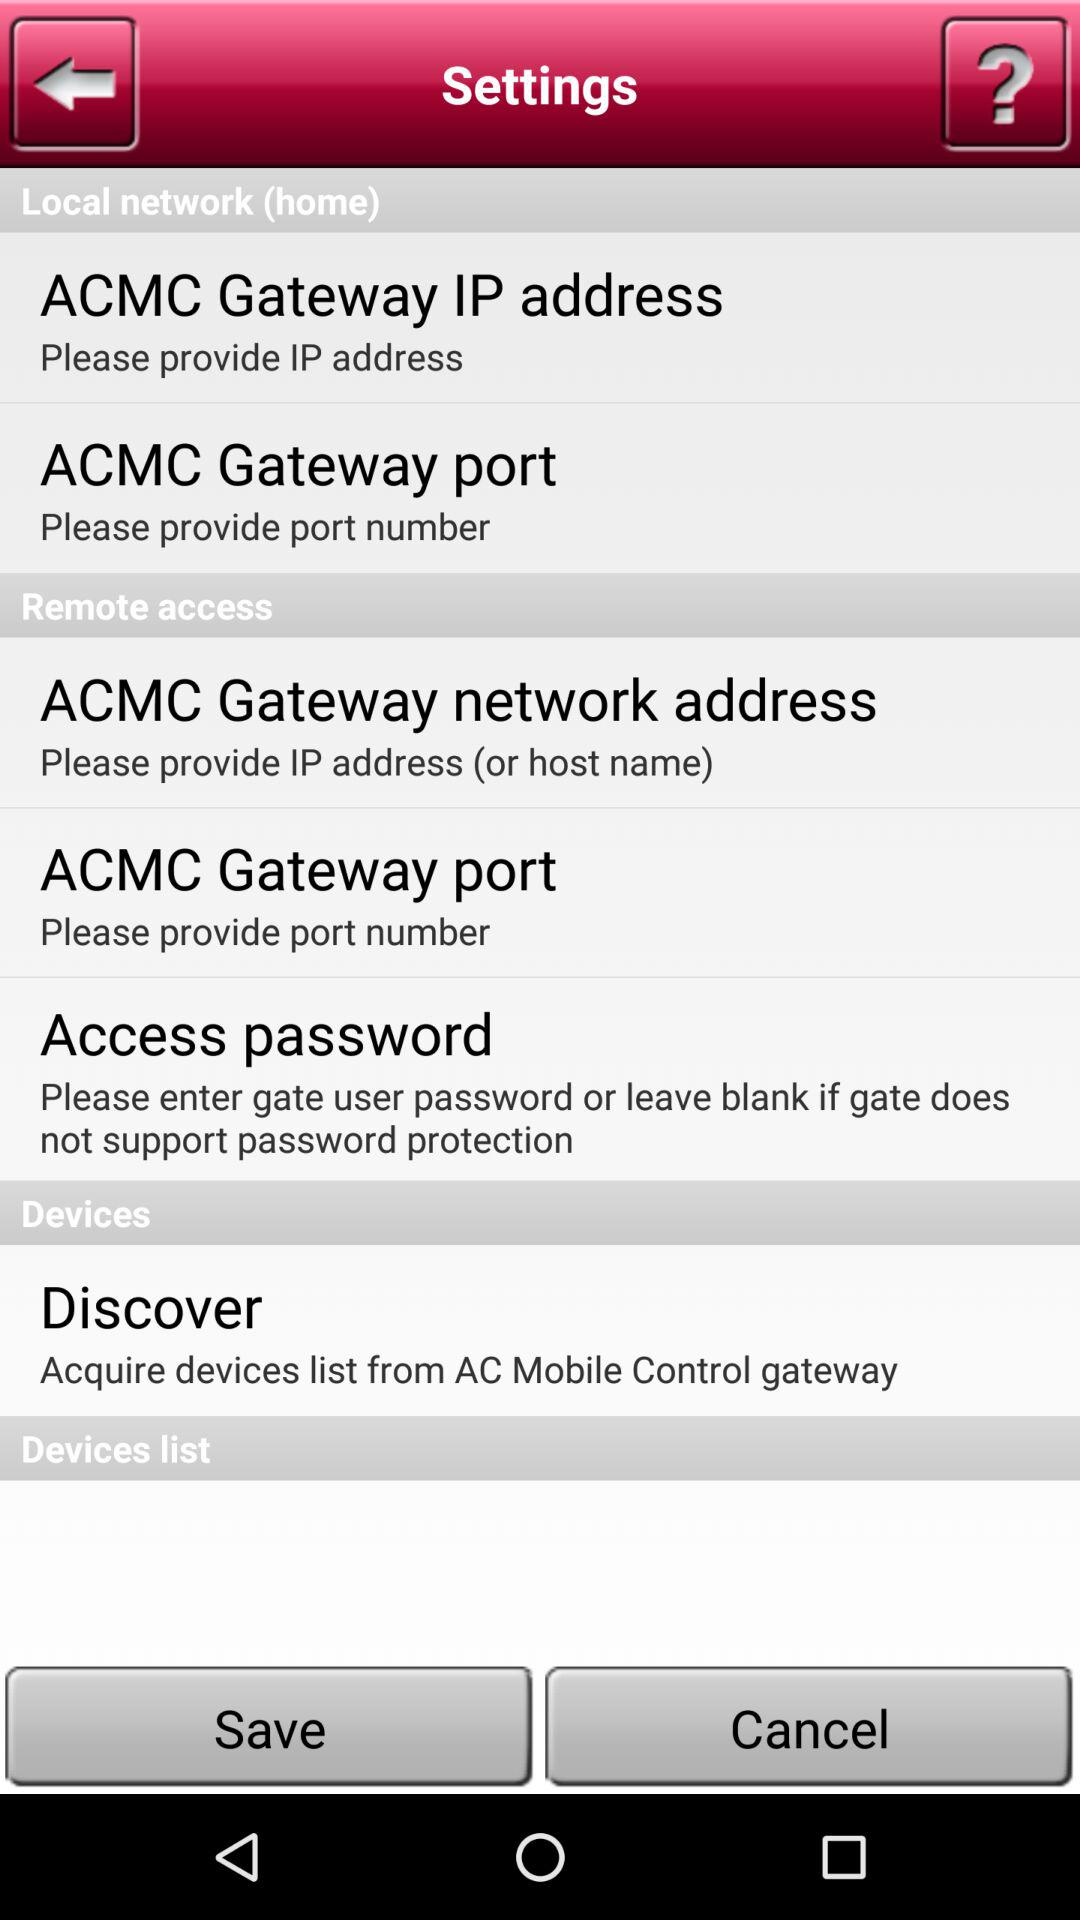How many items have a text field in the Remote Access section?
Answer the question using a single word or phrase. 3 